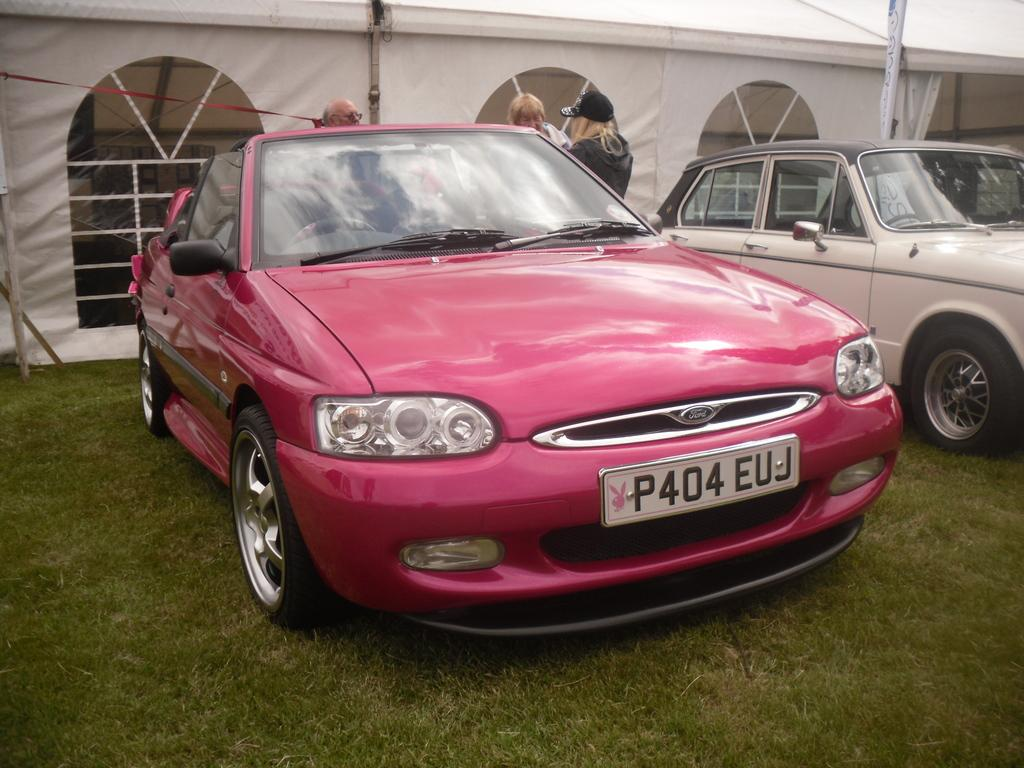<image>
Describe the image concisely. A pink Ford car has a license plate that reads P404EUJ. 